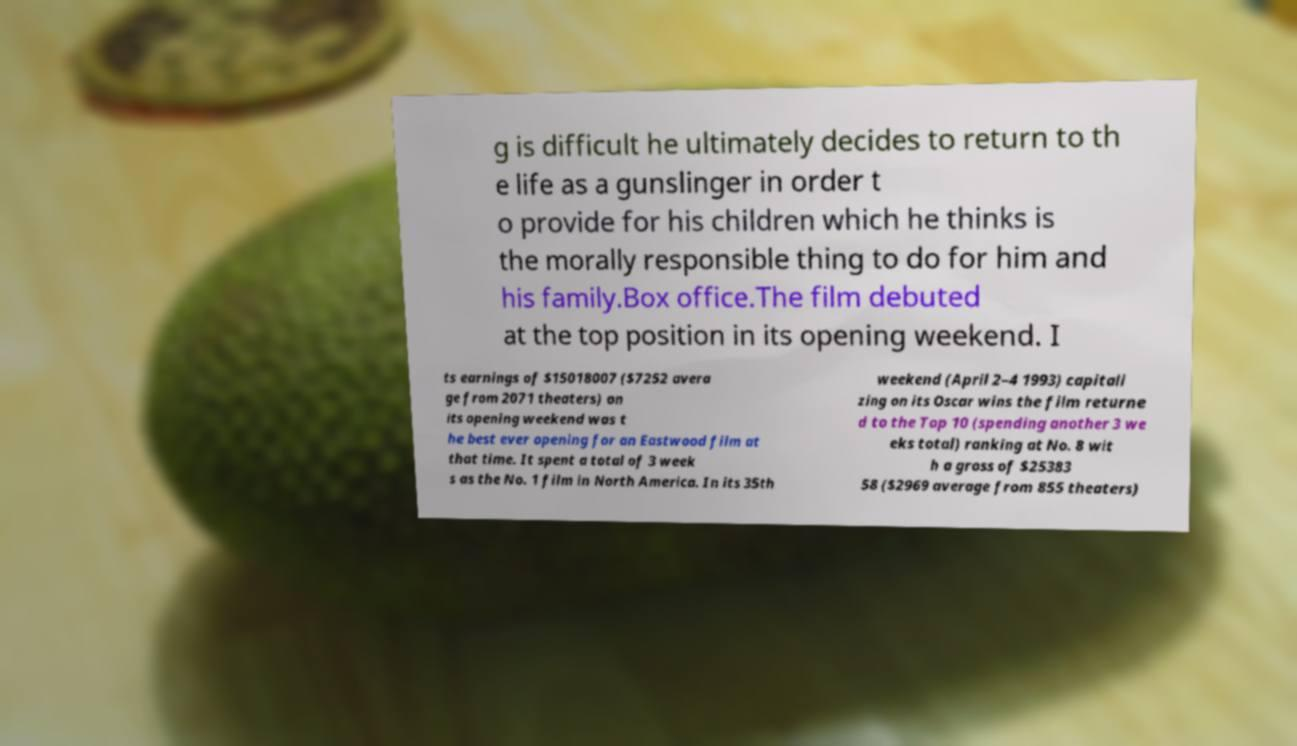Can you read and provide the text displayed in the image?This photo seems to have some interesting text. Can you extract and type it out for me? g is difficult he ultimately decides to return to th e life as a gunslinger in order t o provide for his children which he thinks is the morally responsible thing to do for him and his family.Box office.The film debuted at the top position in its opening weekend. I ts earnings of $15018007 ($7252 avera ge from 2071 theaters) on its opening weekend was t he best ever opening for an Eastwood film at that time. It spent a total of 3 week s as the No. 1 film in North America. In its 35th weekend (April 2–4 1993) capitali zing on its Oscar wins the film returne d to the Top 10 (spending another 3 we eks total) ranking at No. 8 wit h a gross of $25383 58 ($2969 average from 855 theaters) 